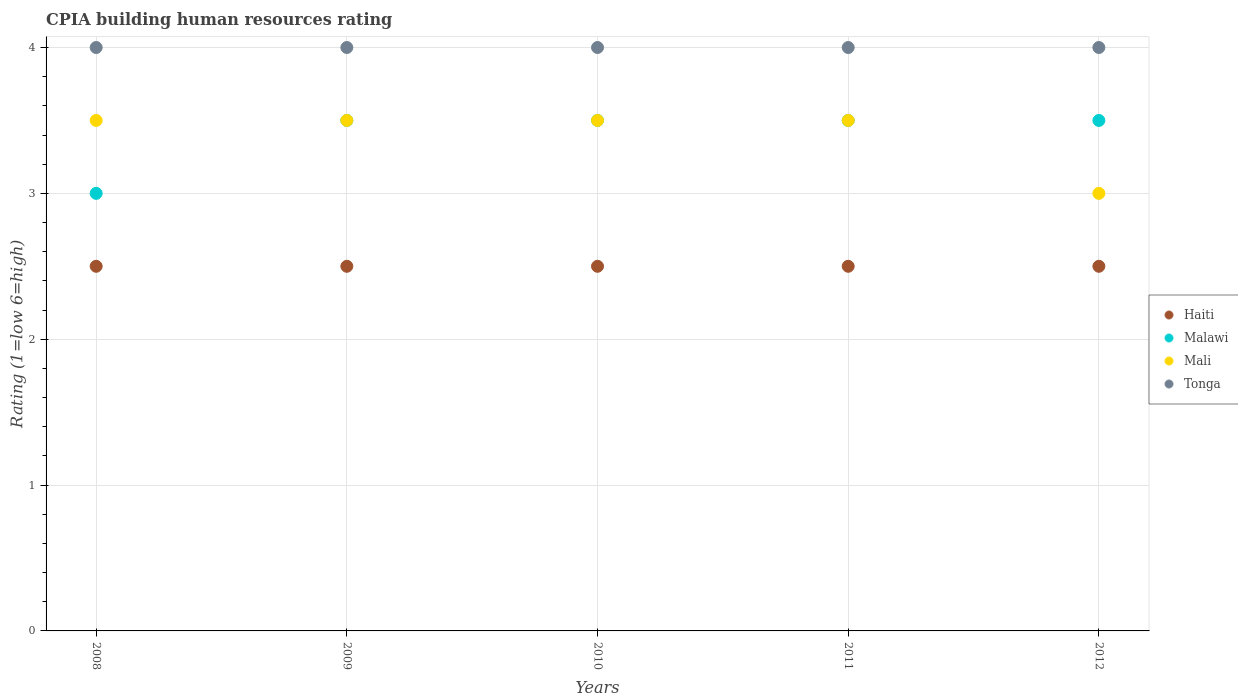How many different coloured dotlines are there?
Offer a very short reply. 4. Is the number of dotlines equal to the number of legend labels?
Ensure brevity in your answer.  Yes. What is the CPIA rating in Mali in 2009?
Offer a terse response. 3.5. Across all years, what is the maximum CPIA rating in Mali?
Keep it short and to the point. 3.5. Across all years, what is the minimum CPIA rating in Tonga?
Your answer should be compact. 4. In which year was the CPIA rating in Malawi minimum?
Keep it short and to the point. 2008. What is the total CPIA rating in Malawi in the graph?
Your response must be concise. 17. What is the difference between the CPIA rating in Haiti in 2008 and that in 2011?
Keep it short and to the point. 0. In the year 2009, what is the difference between the CPIA rating in Mali and CPIA rating in Tonga?
Keep it short and to the point. -0.5. In how many years, is the CPIA rating in Malawi greater than 1.8?
Keep it short and to the point. 5. What is the ratio of the CPIA rating in Malawi in 2010 to that in 2012?
Provide a succinct answer. 1. Is the CPIA rating in Malawi in 2009 less than that in 2010?
Give a very brief answer. No. What is the difference between the highest and the lowest CPIA rating in Mali?
Give a very brief answer. 0.5. In how many years, is the CPIA rating in Malawi greater than the average CPIA rating in Malawi taken over all years?
Make the answer very short. 4. Does the graph contain grids?
Keep it short and to the point. Yes. Where does the legend appear in the graph?
Keep it short and to the point. Center right. How many legend labels are there?
Offer a very short reply. 4. What is the title of the graph?
Ensure brevity in your answer.  CPIA building human resources rating. What is the label or title of the X-axis?
Provide a succinct answer. Years. What is the Rating (1=low 6=high) of Tonga in 2008?
Provide a succinct answer. 4. What is the Rating (1=low 6=high) in Malawi in 2009?
Your answer should be compact. 3.5. What is the Rating (1=low 6=high) of Mali in 2009?
Provide a succinct answer. 3.5. What is the Rating (1=low 6=high) of Malawi in 2010?
Provide a short and direct response. 3.5. What is the Rating (1=low 6=high) in Tonga in 2010?
Offer a terse response. 4. What is the Rating (1=low 6=high) of Haiti in 2011?
Provide a succinct answer. 2.5. What is the Rating (1=low 6=high) of Malawi in 2011?
Your answer should be very brief. 3.5. What is the Rating (1=low 6=high) in Mali in 2011?
Provide a short and direct response. 3.5. What is the Rating (1=low 6=high) of Tonga in 2011?
Offer a terse response. 4. Across all years, what is the maximum Rating (1=low 6=high) in Tonga?
Offer a terse response. 4. Across all years, what is the minimum Rating (1=low 6=high) of Haiti?
Offer a terse response. 2.5. Across all years, what is the minimum Rating (1=low 6=high) in Malawi?
Provide a short and direct response. 3. Across all years, what is the minimum Rating (1=low 6=high) in Mali?
Offer a very short reply. 3. Across all years, what is the minimum Rating (1=low 6=high) in Tonga?
Provide a short and direct response. 4. What is the difference between the Rating (1=low 6=high) in Haiti in 2008 and that in 2009?
Your response must be concise. 0. What is the difference between the Rating (1=low 6=high) of Malawi in 2008 and that in 2009?
Offer a very short reply. -0.5. What is the difference between the Rating (1=low 6=high) in Tonga in 2008 and that in 2009?
Ensure brevity in your answer.  0. What is the difference between the Rating (1=low 6=high) in Mali in 2008 and that in 2010?
Offer a very short reply. 0. What is the difference between the Rating (1=low 6=high) in Haiti in 2008 and that in 2011?
Offer a terse response. 0. What is the difference between the Rating (1=low 6=high) in Tonga in 2008 and that in 2011?
Keep it short and to the point. 0. What is the difference between the Rating (1=low 6=high) of Mali in 2008 and that in 2012?
Provide a succinct answer. 0.5. What is the difference between the Rating (1=low 6=high) in Haiti in 2009 and that in 2010?
Your answer should be compact. 0. What is the difference between the Rating (1=low 6=high) in Tonga in 2009 and that in 2010?
Your answer should be compact. 0. What is the difference between the Rating (1=low 6=high) in Haiti in 2009 and that in 2011?
Ensure brevity in your answer.  0. What is the difference between the Rating (1=low 6=high) in Malawi in 2009 and that in 2011?
Ensure brevity in your answer.  0. What is the difference between the Rating (1=low 6=high) of Tonga in 2009 and that in 2011?
Provide a succinct answer. 0. What is the difference between the Rating (1=low 6=high) in Malawi in 2009 and that in 2012?
Provide a succinct answer. 0. What is the difference between the Rating (1=low 6=high) of Mali in 2009 and that in 2012?
Keep it short and to the point. 0.5. What is the difference between the Rating (1=low 6=high) in Malawi in 2010 and that in 2011?
Offer a terse response. 0. What is the difference between the Rating (1=low 6=high) in Haiti in 2010 and that in 2012?
Offer a very short reply. 0. What is the difference between the Rating (1=low 6=high) of Tonga in 2010 and that in 2012?
Your answer should be very brief. 0. What is the difference between the Rating (1=low 6=high) of Mali in 2011 and that in 2012?
Make the answer very short. 0.5. What is the difference between the Rating (1=low 6=high) of Haiti in 2008 and the Rating (1=low 6=high) of Mali in 2009?
Make the answer very short. -1. What is the difference between the Rating (1=low 6=high) in Haiti in 2008 and the Rating (1=low 6=high) in Malawi in 2010?
Offer a terse response. -1. What is the difference between the Rating (1=low 6=high) in Haiti in 2008 and the Rating (1=low 6=high) in Tonga in 2010?
Provide a short and direct response. -1.5. What is the difference between the Rating (1=low 6=high) of Malawi in 2008 and the Rating (1=low 6=high) of Mali in 2010?
Give a very brief answer. -0.5. What is the difference between the Rating (1=low 6=high) in Malawi in 2008 and the Rating (1=low 6=high) in Tonga in 2010?
Make the answer very short. -1. What is the difference between the Rating (1=low 6=high) in Mali in 2008 and the Rating (1=low 6=high) in Tonga in 2010?
Provide a short and direct response. -0.5. What is the difference between the Rating (1=low 6=high) in Haiti in 2008 and the Rating (1=low 6=high) in Tonga in 2011?
Provide a short and direct response. -1.5. What is the difference between the Rating (1=low 6=high) in Malawi in 2008 and the Rating (1=low 6=high) in Tonga in 2011?
Keep it short and to the point. -1. What is the difference between the Rating (1=low 6=high) of Haiti in 2008 and the Rating (1=low 6=high) of Mali in 2012?
Provide a succinct answer. -0.5. What is the difference between the Rating (1=low 6=high) of Malawi in 2008 and the Rating (1=low 6=high) of Mali in 2012?
Provide a succinct answer. 0. What is the difference between the Rating (1=low 6=high) in Mali in 2008 and the Rating (1=low 6=high) in Tonga in 2012?
Your answer should be compact. -0.5. What is the difference between the Rating (1=low 6=high) of Haiti in 2009 and the Rating (1=low 6=high) of Mali in 2010?
Your answer should be compact. -1. What is the difference between the Rating (1=low 6=high) of Malawi in 2009 and the Rating (1=low 6=high) of Mali in 2010?
Your answer should be very brief. 0. What is the difference between the Rating (1=low 6=high) in Mali in 2009 and the Rating (1=low 6=high) in Tonga in 2010?
Your response must be concise. -0.5. What is the difference between the Rating (1=low 6=high) of Haiti in 2009 and the Rating (1=low 6=high) of Mali in 2011?
Give a very brief answer. -1. What is the difference between the Rating (1=low 6=high) of Haiti in 2009 and the Rating (1=low 6=high) of Tonga in 2011?
Keep it short and to the point. -1.5. What is the difference between the Rating (1=low 6=high) of Haiti in 2009 and the Rating (1=low 6=high) of Tonga in 2012?
Your answer should be compact. -1.5. What is the difference between the Rating (1=low 6=high) of Malawi in 2009 and the Rating (1=low 6=high) of Mali in 2012?
Offer a very short reply. 0.5. What is the difference between the Rating (1=low 6=high) in Haiti in 2010 and the Rating (1=low 6=high) in Malawi in 2011?
Keep it short and to the point. -1. What is the difference between the Rating (1=low 6=high) of Haiti in 2010 and the Rating (1=low 6=high) of Mali in 2011?
Give a very brief answer. -1. What is the difference between the Rating (1=low 6=high) of Malawi in 2010 and the Rating (1=low 6=high) of Tonga in 2011?
Your answer should be very brief. -0.5. What is the difference between the Rating (1=low 6=high) of Mali in 2010 and the Rating (1=low 6=high) of Tonga in 2011?
Provide a succinct answer. -0.5. What is the difference between the Rating (1=low 6=high) of Haiti in 2010 and the Rating (1=low 6=high) of Malawi in 2012?
Give a very brief answer. -1. What is the difference between the Rating (1=low 6=high) in Malawi in 2010 and the Rating (1=low 6=high) in Mali in 2012?
Offer a terse response. 0.5. What is the difference between the Rating (1=low 6=high) in Haiti in 2011 and the Rating (1=low 6=high) in Malawi in 2012?
Give a very brief answer. -1. What is the difference between the Rating (1=low 6=high) of Malawi in 2011 and the Rating (1=low 6=high) of Tonga in 2012?
Give a very brief answer. -0.5. What is the average Rating (1=low 6=high) of Malawi per year?
Keep it short and to the point. 3.4. What is the average Rating (1=low 6=high) of Mali per year?
Provide a short and direct response. 3.4. In the year 2008, what is the difference between the Rating (1=low 6=high) of Malawi and Rating (1=low 6=high) of Tonga?
Provide a succinct answer. -1. In the year 2008, what is the difference between the Rating (1=low 6=high) of Mali and Rating (1=low 6=high) of Tonga?
Your response must be concise. -0.5. In the year 2009, what is the difference between the Rating (1=low 6=high) of Haiti and Rating (1=low 6=high) of Mali?
Your response must be concise. -1. In the year 2009, what is the difference between the Rating (1=low 6=high) in Haiti and Rating (1=low 6=high) in Tonga?
Ensure brevity in your answer.  -1.5. In the year 2009, what is the difference between the Rating (1=low 6=high) of Malawi and Rating (1=low 6=high) of Tonga?
Give a very brief answer. -0.5. In the year 2010, what is the difference between the Rating (1=low 6=high) in Haiti and Rating (1=low 6=high) in Mali?
Offer a terse response. -1. In the year 2010, what is the difference between the Rating (1=low 6=high) of Haiti and Rating (1=low 6=high) of Tonga?
Your response must be concise. -1.5. In the year 2010, what is the difference between the Rating (1=low 6=high) of Malawi and Rating (1=low 6=high) of Mali?
Provide a succinct answer. 0. In the year 2010, what is the difference between the Rating (1=low 6=high) of Malawi and Rating (1=low 6=high) of Tonga?
Keep it short and to the point. -0.5. In the year 2010, what is the difference between the Rating (1=low 6=high) in Mali and Rating (1=low 6=high) in Tonga?
Provide a short and direct response. -0.5. In the year 2011, what is the difference between the Rating (1=low 6=high) in Haiti and Rating (1=low 6=high) in Malawi?
Give a very brief answer. -1. In the year 2011, what is the difference between the Rating (1=low 6=high) of Haiti and Rating (1=low 6=high) of Mali?
Keep it short and to the point. -1. In the year 2011, what is the difference between the Rating (1=low 6=high) of Malawi and Rating (1=low 6=high) of Mali?
Offer a terse response. 0. In the year 2011, what is the difference between the Rating (1=low 6=high) in Mali and Rating (1=low 6=high) in Tonga?
Keep it short and to the point. -0.5. In the year 2012, what is the difference between the Rating (1=low 6=high) in Haiti and Rating (1=low 6=high) in Malawi?
Your answer should be compact. -1. In the year 2012, what is the difference between the Rating (1=low 6=high) in Malawi and Rating (1=low 6=high) in Mali?
Your answer should be compact. 0.5. In the year 2012, what is the difference between the Rating (1=low 6=high) in Malawi and Rating (1=low 6=high) in Tonga?
Give a very brief answer. -0.5. In the year 2012, what is the difference between the Rating (1=low 6=high) of Mali and Rating (1=low 6=high) of Tonga?
Ensure brevity in your answer.  -1. What is the ratio of the Rating (1=low 6=high) of Malawi in 2008 to that in 2009?
Keep it short and to the point. 0.86. What is the ratio of the Rating (1=low 6=high) of Haiti in 2008 to that in 2010?
Provide a short and direct response. 1. What is the ratio of the Rating (1=low 6=high) of Mali in 2008 to that in 2010?
Keep it short and to the point. 1. What is the ratio of the Rating (1=low 6=high) of Tonga in 2008 to that in 2010?
Make the answer very short. 1. What is the ratio of the Rating (1=low 6=high) of Haiti in 2008 to that in 2011?
Keep it short and to the point. 1. What is the ratio of the Rating (1=low 6=high) of Haiti in 2008 to that in 2012?
Offer a terse response. 1. What is the ratio of the Rating (1=low 6=high) of Mali in 2008 to that in 2012?
Your answer should be compact. 1.17. What is the ratio of the Rating (1=low 6=high) of Haiti in 2009 to that in 2011?
Offer a very short reply. 1. What is the ratio of the Rating (1=low 6=high) of Malawi in 2009 to that in 2011?
Your answer should be very brief. 1. What is the ratio of the Rating (1=low 6=high) of Malawi in 2009 to that in 2012?
Provide a short and direct response. 1. What is the ratio of the Rating (1=low 6=high) of Tonga in 2009 to that in 2012?
Make the answer very short. 1. What is the ratio of the Rating (1=low 6=high) of Haiti in 2010 to that in 2011?
Your answer should be very brief. 1. What is the ratio of the Rating (1=low 6=high) of Tonga in 2010 to that in 2011?
Keep it short and to the point. 1. What is the ratio of the Rating (1=low 6=high) of Malawi in 2011 to that in 2012?
Provide a succinct answer. 1. What is the ratio of the Rating (1=low 6=high) of Mali in 2011 to that in 2012?
Provide a short and direct response. 1.17. What is the difference between the highest and the second highest Rating (1=low 6=high) in Mali?
Provide a short and direct response. 0. What is the difference between the highest and the second highest Rating (1=low 6=high) of Tonga?
Keep it short and to the point. 0. What is the difference between the highest and the lowest Rating (1=low 6=high) of Mali?
Your response must be concise. 0.5. 